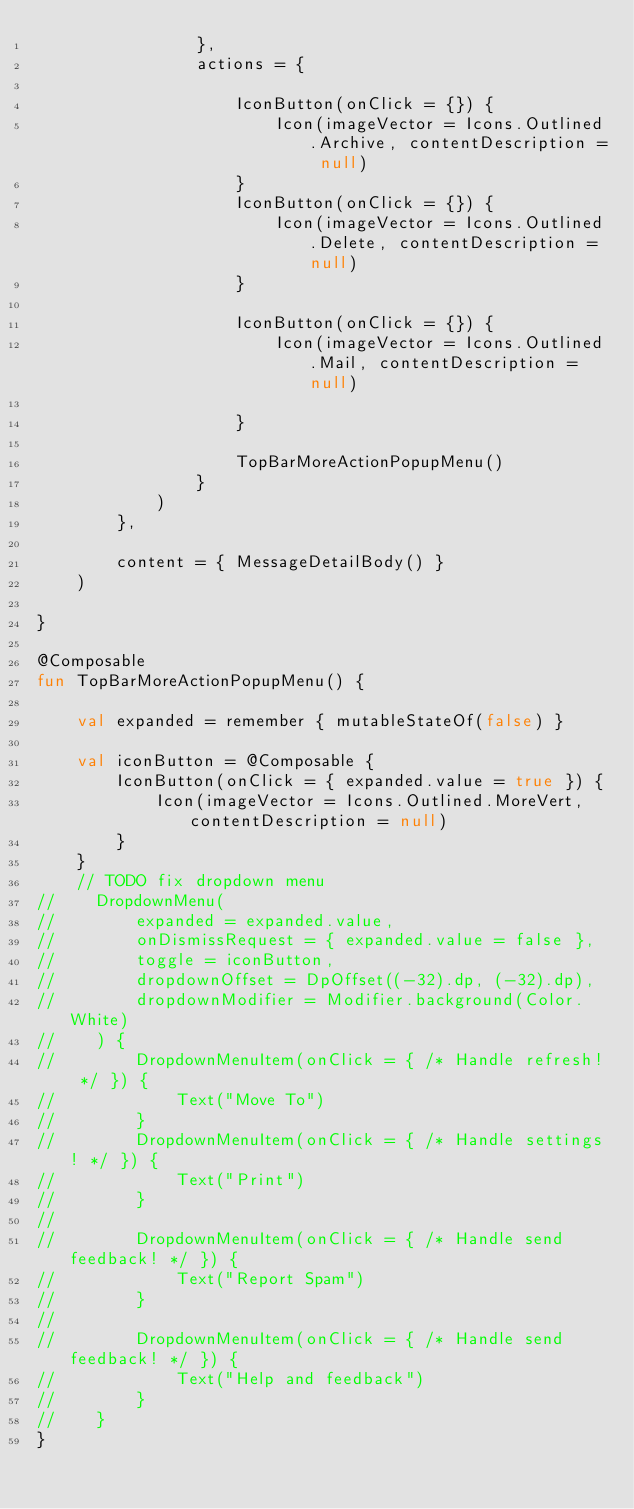Convert code to text. <code><loc_0><loc_0><loc_500><loc_500><_Kotlin_>                },
                actions = {

                    IconButton(onClick = {}) {
                        Icon(imageVector = Icons.Outlined.Archive, contentDescription = null)
                    }
                    IconButton(onClick = {}) {
                        Icon(imageVector = Icons.Outlined.Delete, contentDescription = null)
                    }

                    IconButton(onClick = {}) {
                        Icon(imageVector = Icons.Outlined.Mail, contentDescription = null)

                    }

                    TopBarMoreActionPopupMenu()
                }
            )
        },

        content = { MessageDetailBody() }
    )

}

@Composable
fun TopBarMoreActionPopupMenu() {

    val expanded = remember { mutableStateOf(false) }

    val iconButton = @Composable {
        IconButton(onClick = { expanded.value = true }) {
            Icon(imageVector = Icons.Outlined.MoreVert, contentDescription = null)
        }
    }
    // TODO fix dropdown menu
//    DropdownMenu(
//        expanded = expanded.value,
//        onDismissRequest = { expanded.value = false },
//        toggle = iconButton,
//        dropdownOffset = DpOffset((-32).dp, (-32).dp),
//        dropdownModifier = Modifier.background(Color.White)
//    ) {
//        DropdownMenuItem(onClick = { /* Handle refresh! */ }) {
//            Text("Move To")
//        }
//        DropdownMenuItem(onClick = { /* Handle settings! */ }) {
//            Text("Print")
//        }
//
//        DropdownMenuItem(onClick = { /* Handle send feedback! */ }) {
//            Text("Report Spam")
//        }
//
//        DropdownMenuItem(onClick = { /* Handle send feedback! */ }) {
//            Text("Help and feedback")
//        }
//    }
}
</code> 